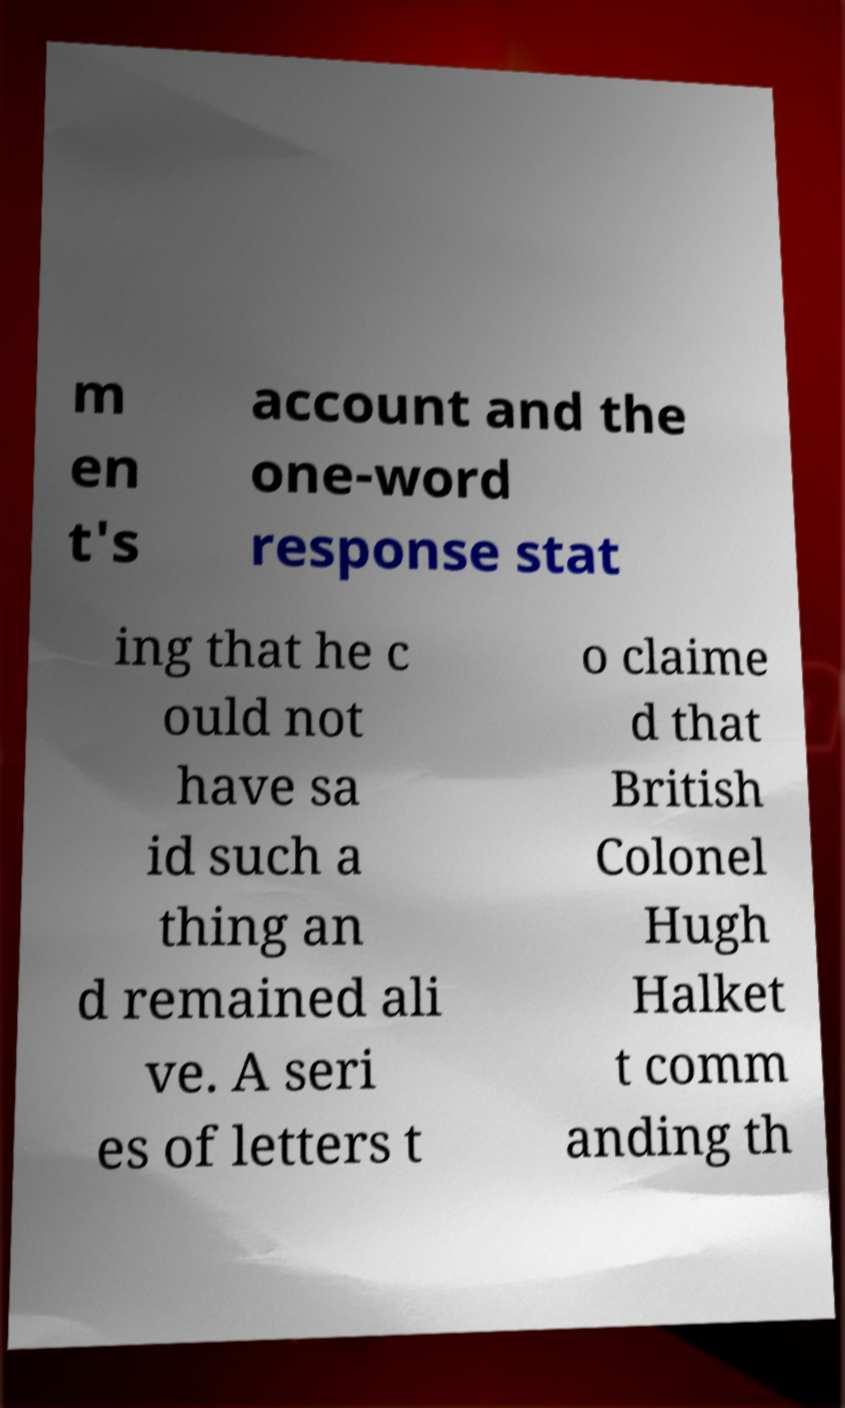Please read and relay the text visible in this image. What does it say? m en t's account and the one-word response stat ing that he c ould not have sa id such a thing an d remained ali ve. A seri es of letters t o claime d that British Colonel Hugh Halket t comm anding th 